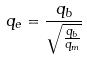Convert formula to latex. <formula><loc_0><loc_0><loc_500><loc_500>q _ { e } = \frac { q _ { b } } { \sqrt { \frac { q _ { b } } { q _ { m } } } }</formula> 